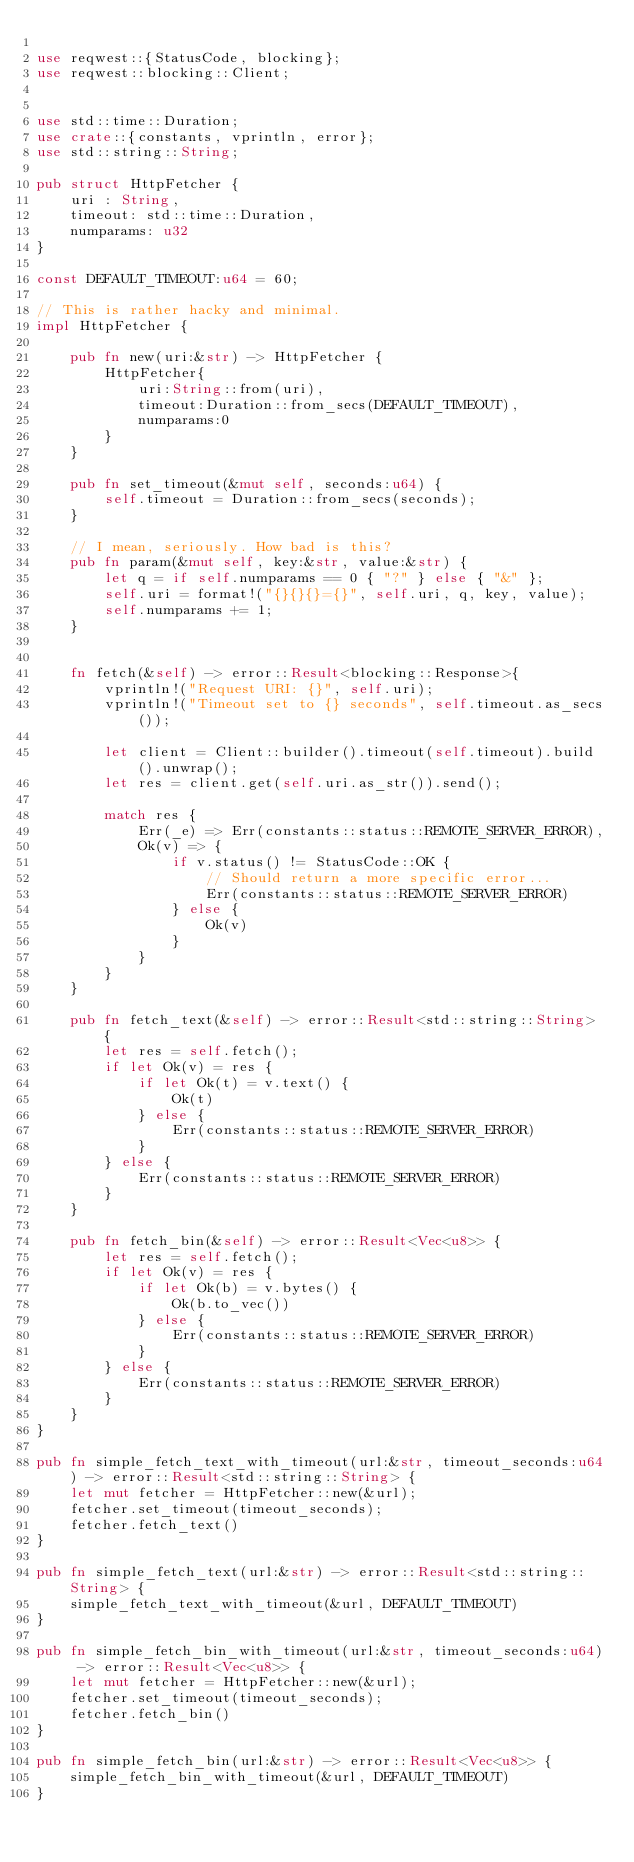<code> <loc_0><loc_0><loc_500><loc_500><_Rust_>
use reqwest::{StatusCode, blocking};
use reqwest::blocking::Client;


use std::time::Duration;
use crate::{constants, vprintln, error};
use std::string::String;

pub struct HttpFetcher {
    uri : String,
    timeout: std::time::Duration,
    numparams: u32
}

const DEFAULT_TIMEOUT:u64 = 60;

// This is rather hacky and minimal.
impl HttpFetcher {

    pub fn new(uri:&str) -> HttpFetcher {
        HttpFetcher{
            uri:String::from(uri),
            timeout:Duration::from_secs(DEFAULT_TIMEOUT),
            numparams:0
        }
    }

    pub fn set_timeout(&mut self, seconds:u64) {
        self.timeout = Duration::from_secs(seconds);
    }

    // I mean, seriously. How bad is this?
    pub fn param(&mut self, key:&str, value:&str) {
        let q = if self.numparams == 0 { "?" } else { "&" };
        self.uri = format!("{}{}{}={}", self.uri, q, key, value);
        self.numparams += 1;
    }


    fn fetch(&self) -> error::Result<blocking::Response>{
        vprintln!("Request URI: {}", self.uri);
        vprintln!("Timeout set to {} seconds", self.timeout.as_secs());

        let client = Client::builder().timeout(self.timeout).build().unwrap();
        let res = client.get(self.uri.as_str()).send();

        match res {
            Err(_e) => Err(constants::status::REMOTE_SERVER_ERROR),
            Ok(v) => {
                if v.status() != StatusCode::OK {
                    // Should return a more specific error...
                    Err(constants::status::REMOTE_SERVER_ERROR)
                } else {
                    Ok(v)
                }
            }
        }
    }

    pub fn fetch_text(&self) -> error::Result<std::string::String> {
        let res = self.fetch();
        if let Ok(v) = res {
            if let Ok(t) = v.text() {
                Ok(t)
            } else {
                Err(constants::status::REMOTE_SERVER_ERROR)
            }
        } else {
            Err(constants::status::REMOTE_SERVER_ERROR)
        }
    }

    pub fn fetch_bin(&self) -> error::Result<Vec<u8>> {
        let res = self.fetch();
        if let Ok(v) = res {
            if let Ok(b) = v.bytes() {
                Ok(b.to_vec())
            } else {
                Err(constants::status::REMOTE_SERVER_ERROR)
            }
        } else {
            Err(constants::status::REMOTE_SERVER_ERROR)
        }
    }
}

pub fn simple_fetch_text_with_timeout(url:&str, timeout_seconds:u64) -> error::Result<std::string::String> {
    let mut fetcher = HttpFetcher::new(&url);
    fetcher.set_timeout(timeout_seconds);
    fetcher.fetch_text()
}

pub fn simple_fetch_text(url:&str) -> error::Result<std::string::String> {
    simple_fetch_text_with_timeout(&url, DEFAULT_TIMEOUT)
}

pub fn simple_fetch_bin_with_timeout(url:&str, timeout_seconds:u64) -> error::Result<Vec<u8>> {
    let mut fetcher = HttpFetcher::new(&url);
    fetcher.set_timeout(timeout_seconds);
    fetcher.fetch_bin()
}

pub fn simple_fetch_bin(url:&str) -> error::Result<Vec<u8>> {
    simple_fetch_bin_with_timeout(&url, DEFAULT_TIMEOUT)
}</code> 